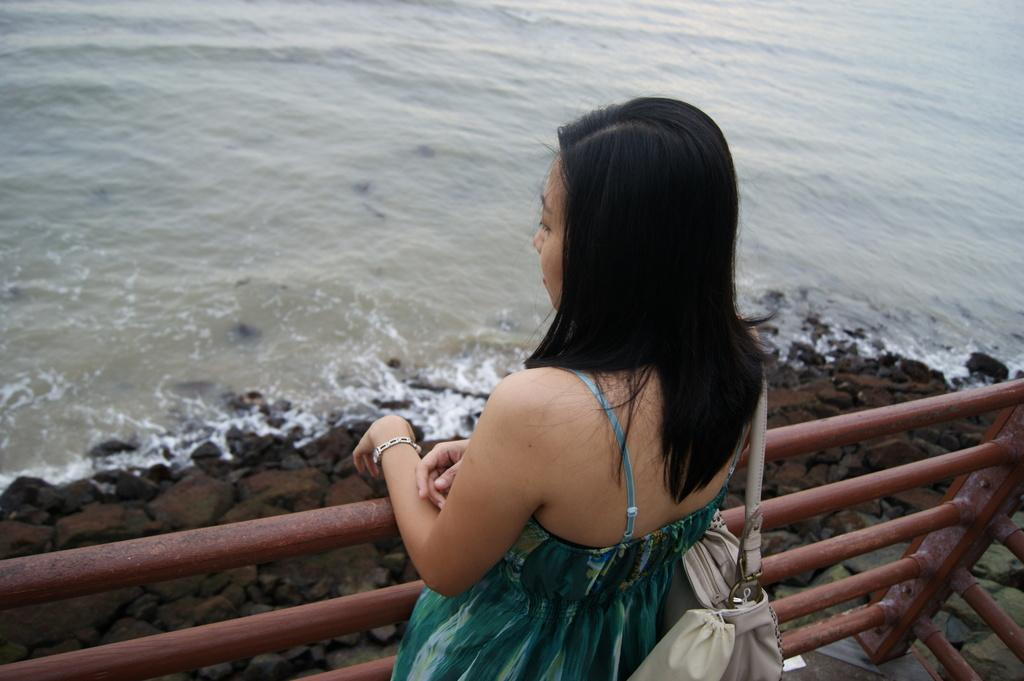What is the main subject of the image? There is a woman standing in the image. What is the woman wearing in the image? The woman is wearing a bag. What other objects can be seen in the image? There is a metal rod and rocks visible in the image. What is the natural element present in the image? There is water visible in the image. What type of account does the woman have at the library in the image? There is no library or account mentioned in the image; it only features a woman standing, a bag, a metal rod, rocks, and water. 